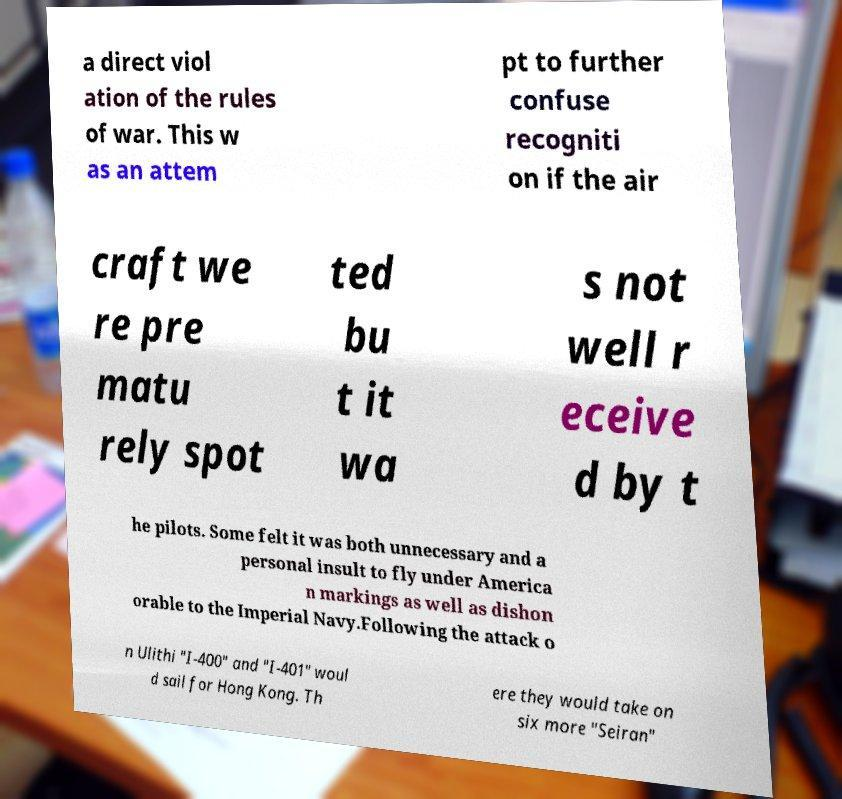For documentation purposes, I need the text within this image transcribed. Could you provide that? a direct viol ation of the rules of war. This w as an attem pt to further confuse recogniti on if the air craft we re pre matu rely spot ted bu t it wa s not well r eceive d by t he pilots. Some felt it was both unnecessary and a personal insult to fly under America n markings as well as dishon orable to the Imperial Navy.Following the attack o n Ulithi "I-400" and "I-401" woul d sail for Hong Kong. Th ere they would take on six more "Seiran" 